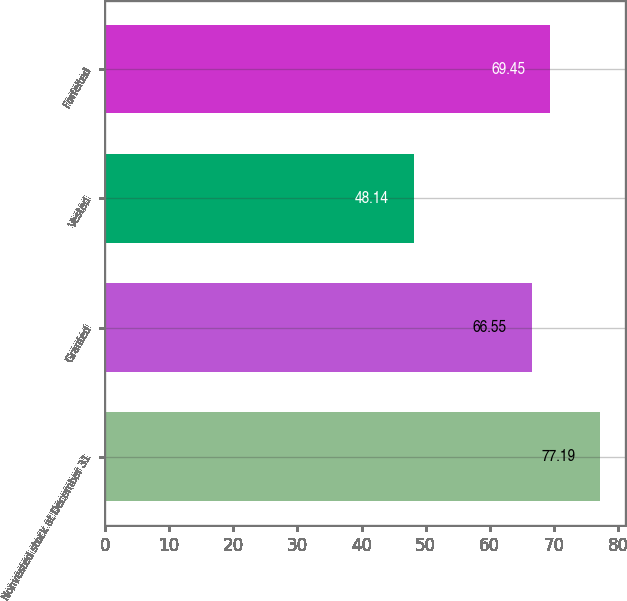<chart> <loc_0><loc_0><loc_500><loc_500><bar_chart><fcel>Nonvested stock at December 31<fcel>Granted<fcel>Vested<fcel>Forfeited<nl><fcel>77.19<fcel>66.55<fcel>48.14<fcel>69.45<nl></chart> 